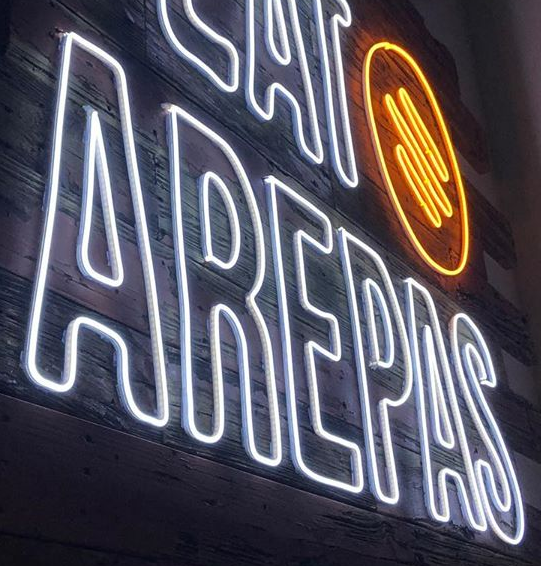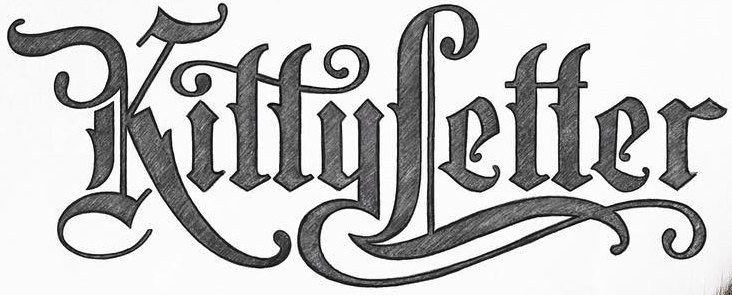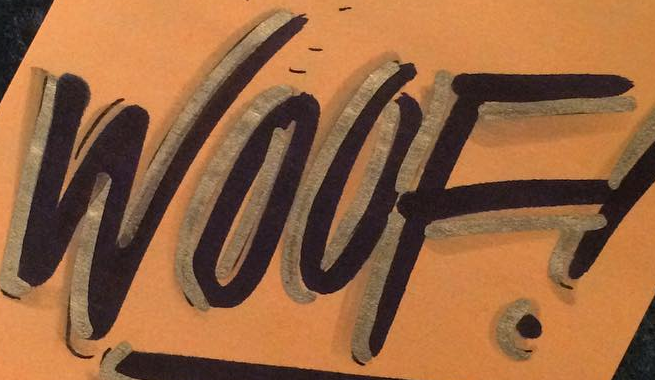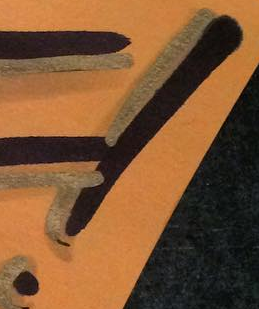Read the text from these images in sequence, separated by a semicolon. AREPAS; KittyLetter; WOOF; ! 